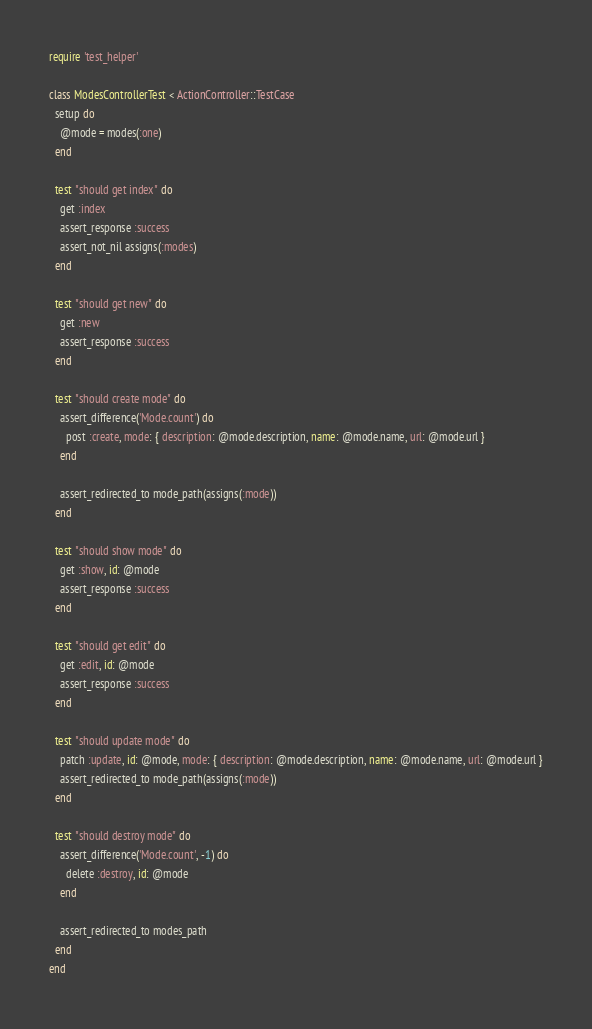Convert code to text. <code><loc_0><loc_0><loc_500><loc_500><_Ruby_>require 'test_helper'

class ModesControllerTest < ActionController::TestCase
  setup do
    @mode = modes(:one)
  end

  test "should get index" do
    get :index
    assert_response :success
    assert_not_nil assigns(:modes)
  end

  test "should get new" do
    get :new
    assert_response :success
  end

  test "should create mode" do
    assert_difference('Mode.count') do
      post :create, mode: { description: @mode.description, name: @mode.name, url: @mode.url }
    end

    assert_redirected_to mode_path(assigns(:mode))
  end

  test "should show mode" do
    get :show, id: @mode
    assert_response :success
  end

  test "should get edit" do
    get :edit, id: @mode
    assert_response :success
  end

  test "should update mode" do
    patch :update, id: @mode, mode: { description: @mode.description, name: @mode.name, url: @mode.url }
    assert_redirected_to mode_path(assigns(:mode))
  end

  test "should destroy mode" do
    assert_difference('Mode.count', -1) do
      delete :destroy, id: @mode
    end

    assert_redirected_to modes_path
  end
end
</code> 